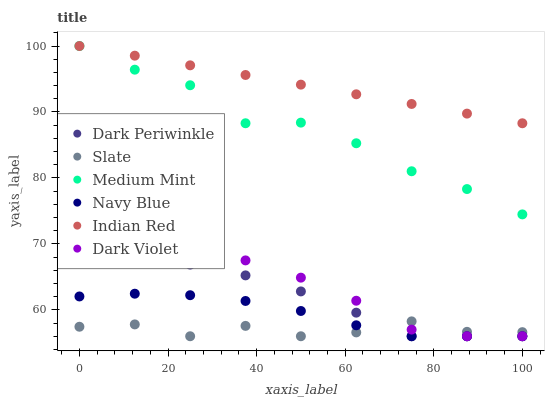Does Slate have the minimum area under the curve?
Answer yes or no. Yes. Does Indian Red have the maximum area under the curve?
Answer yes or no. Yes. Does Navy Blue have the minimum area under the curve?
Answer yes or no. No. Does Navy Blue have the maximum area under the curve?
Answer yes or no. No. Is Indian Red the smoothest?
Answer yes or no. Yes. Is Medium Mint the roughest?
Answer yes or no. Yes. Is Navy Blue the smoothest?
Answer yes or no. No. Is Navy Blue the roughest?
Answer yes or no. No. Does Navy Blue have the lowest value?
Answer yes or no. Yes. Does Indian Red have the lowest value?
Answer yes or no. No. Does Indian Red have the highest value?
Answer yes or no. Yes. Does Navy Blue have the highest value?
Answer yes or no. No. Is Dark Violet less than Indian Red?
Answer yes or no. Yes. Is Indian Red greater than Navy Blue?
Answer yes or no. Yes. Does Navy Blue intersect Dark Periwinkle?
Answer yes or no. Yes. Is Navy Blue less than Dark Periwinkle?
Answer yes or no. No. Is Navy Blue greater than Dark Periwinkle?
Answer yes or no. No. Does Dark Violet intersect Indian Red?
Answer yes or no. No. 